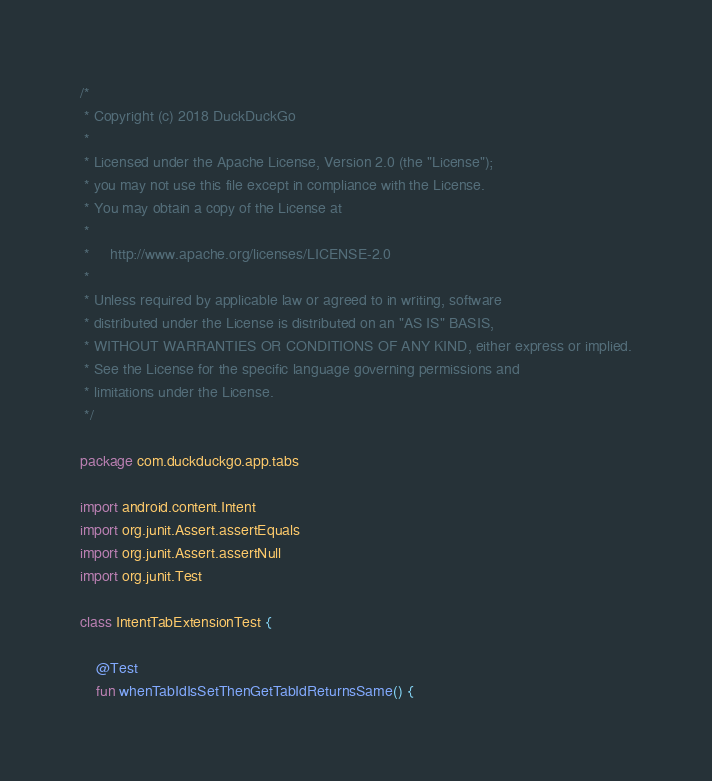Convert code to text. <code><loc_0><loc_0><loc_500><loc_500><_Kotlin_>/*
 * Copyright (c) 2018 DuckDuckGo
 *
 * Licensed under the Apache License, Version 2.0 (the "License");
 * you may not use this file except in compliance with the License.
 * You may obtain a copy of the License at
 *
 *     http://www.apache.org/licenses/LICENSE-2.0
 *
 * Unless required by applicable law or agreed to in writing, software
 * distributed under the License is distributed on an "AS IS" BASIS,
 * WITHOUT WARRANTIES OR CONDITIONS OF ANY KIND, either express or implied.
 * See the License for the specific language governing permissions and
 * limitations under the License.
 */

package com.duckduckgo.app.tabs

import android.content.Intent
import org.junit.Assert.assertEquals
import org.junit.Assert.assertNull
import org.junit.Test

class IntentTabExtensionTest {

    @Test
    fun whenTabIdIsSetThenGetTabIdReturnsSame() {</code> 